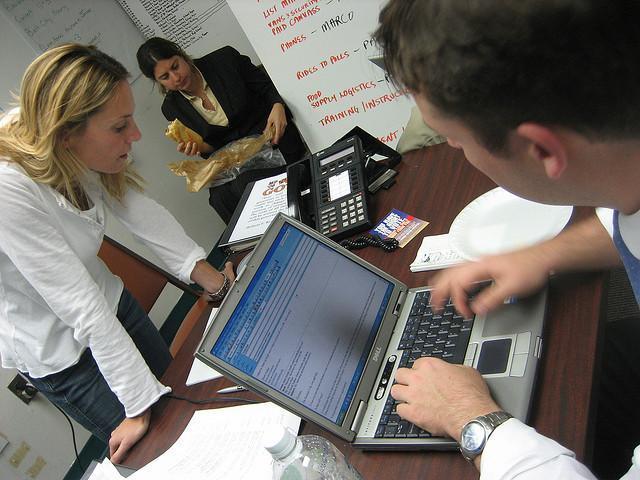How many people have watches?
Give a very brief answer. 2. How many people are in the picture?
Give a very brief answer. 3. 